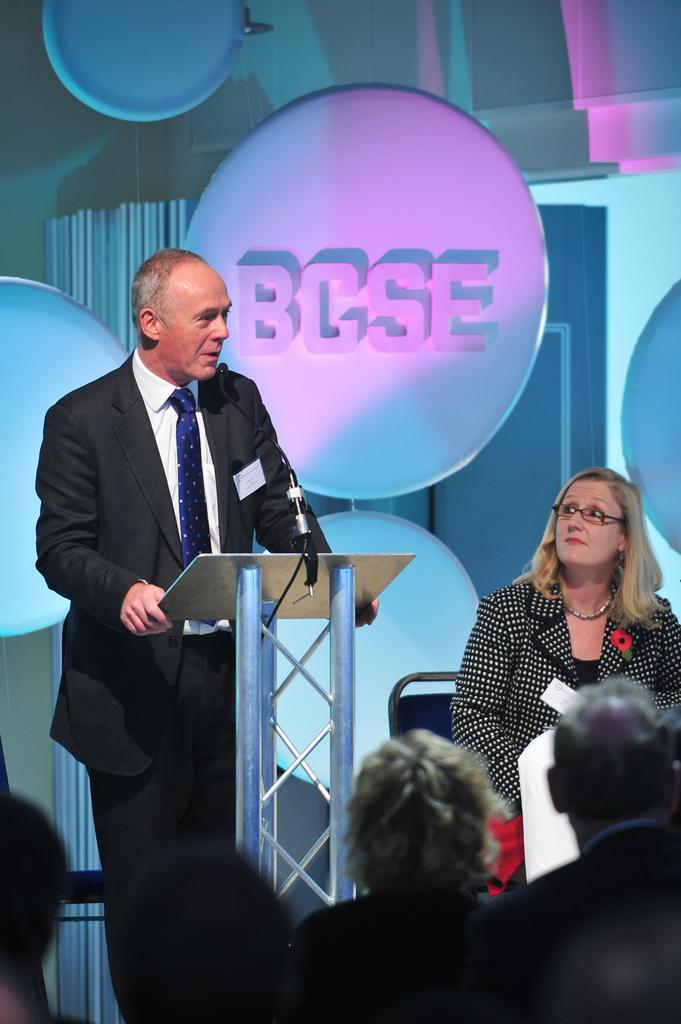How many people are in the image? There is a group of people in the image. What is the position of one of the people in the image? There is a person sitting on a chair. What is the man near in the image? There is a man standing near a podium. What device is present for amplifying sound in the image? There is a microphone (mike) in the image. What can be seen in the background of the image? There are boards visible in the background of the image. Can you tell me how deep the river is in the image? There is no river present in the image; it features a group of people, a person sitting on a chair, a man standing near a podium, a microphone, and boards in the background. 